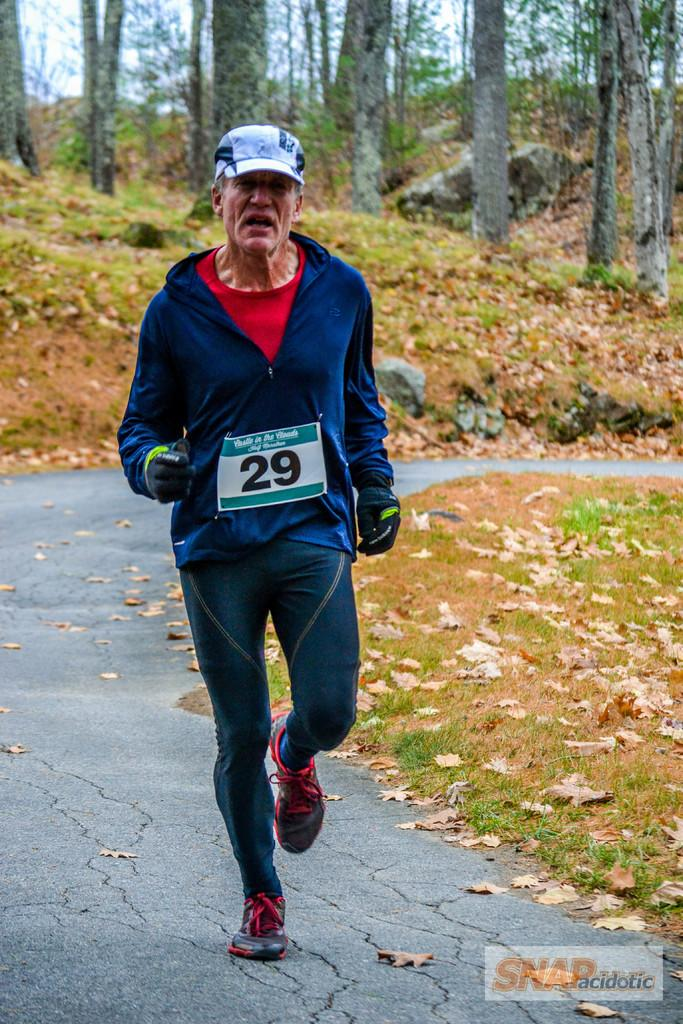Who is the main subject in the image? There is a man in the image. What is the man doing in the image? The man is running on the road. What can be seen in the background of the image? There are trees, grass, and the sky visible in the background of the image. What type of fish can be seen swimming in the image? There are no fish present in the image; it features a man running on the road with trees, grass, and the sky visible in the background. 